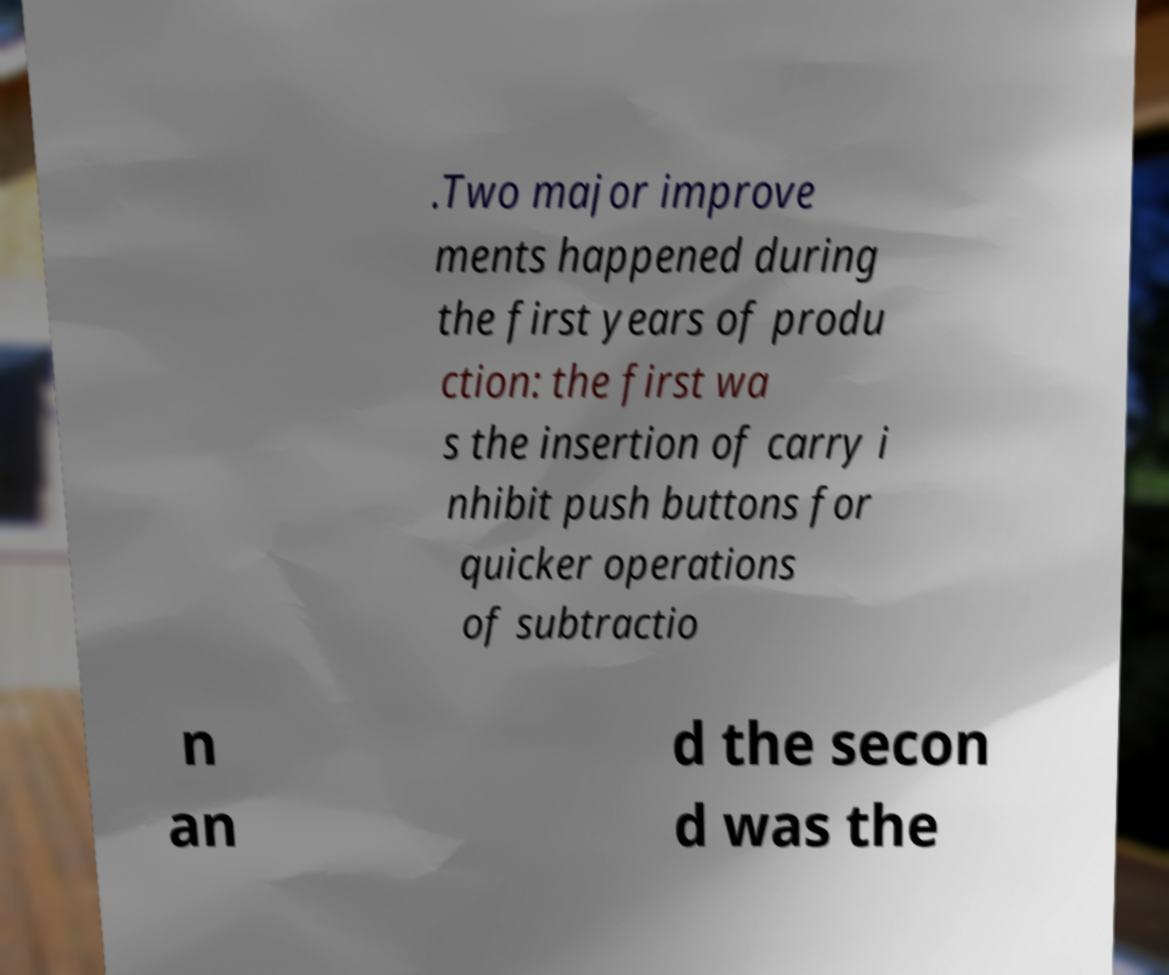Could you extract and type out the text from this image? .Two major improve ments happened during the first years of produ ction: the first wa s the insertion of carry i nhibit push buttons for quicker operations of subtractio n an d the secon d was the 